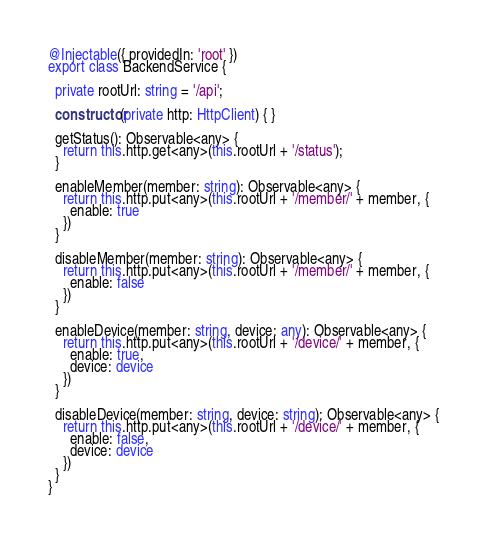<code> <loc_0><loc_0><loc_500><loc_500><_TypeScript_>@Injectable({ providedIn: 'root' })
export class BackendService {

  private rootUrl: string = '/api';

  constructor(private http: HttpClient) { }

  getStatus(): Observable<any> {
    return this.http.get<any>(this.rootUrl + '/status');
  }

  enableMember(member: string): Observable<any> {
    return this.http.put<any>(this.rootUrl + '/member/' + member, {
      enable: true
    })
  }

  disableMember(member: string): Observable<any> {
    return this.http.put<any>(this.rootUrl + '/member/' + member, {
      enable: false
    })
  }

  enableDevice(member: string, device: any): Observable<any> {
    return this.http.put<any>(this.rootUrl + '/device/' + member, {
      enable: true,
      device: device
    })
  }

  disableDevice(member: string, device: string): Observable<any> {
    return this.http.put<any>(this.rootUrl + '/device/' + member, {
      enable: false,
      device: device
    })
  }
}</code> 